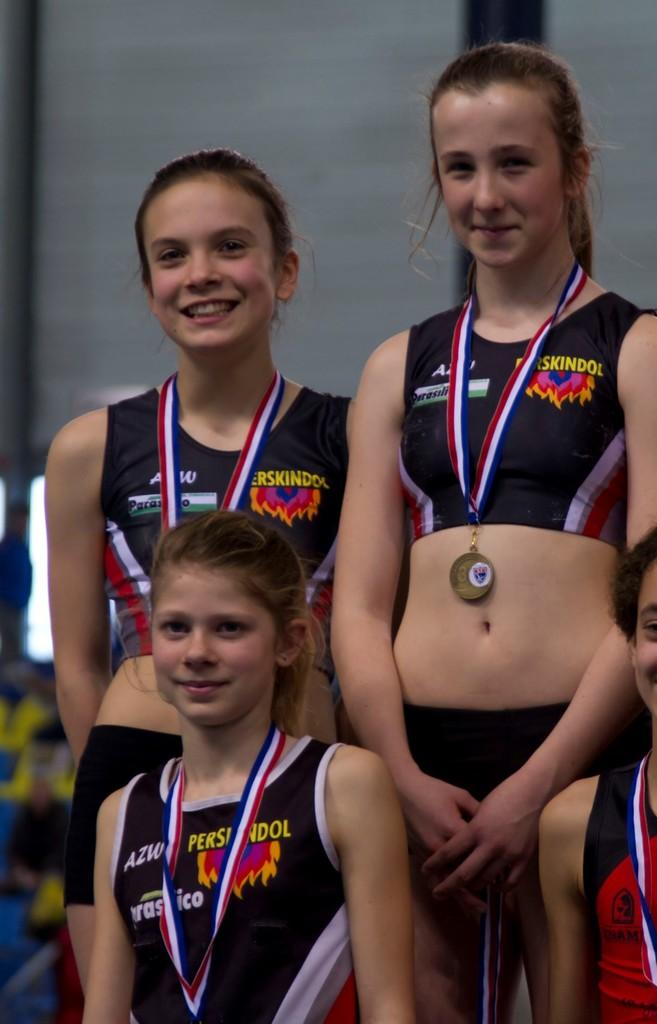<image>
Offer a succinct explanation of the picture presented. A group of girls are standing on a podium wearing medals and their uniforms say Perskindol. 